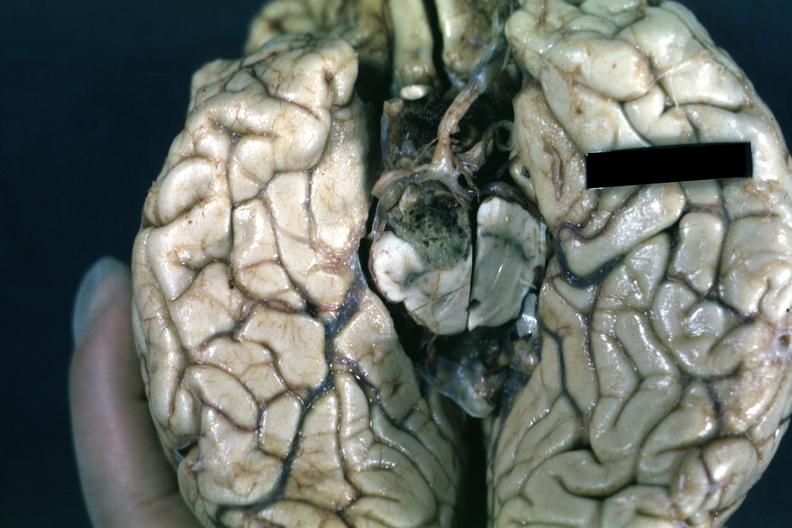what does this image show?
Answer the question using a single word or phrase. Fixed tissue inferior view of cerebral hemisphere with cerebellum and brainstexcised 